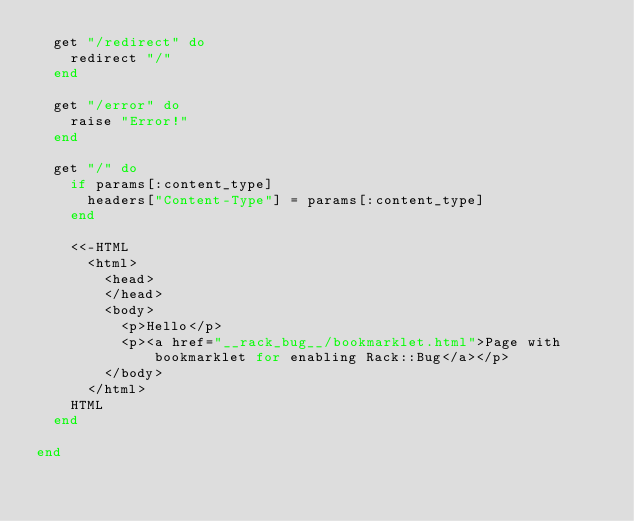Convert code to text. <code><loc_0><loc_0><loc_500><loc_500><_Ruby_>  get "/redirect" do
    redirect "/"
  end

  get "/error" do
    raise "Error!"
  end

  get "/" do
    if params[:content_type]
      headers["Content-Type"] = params[:content_type]
    end

    <<-HTML
      <html>
        <head>
        </head>
        <body>
          <p>Hello</p>
          <p><a href="__rack_bug__/bookmarklet.html">Page with bookmarklet for enabling Rack::Bug</a></p>
        </body>
      </html>
    HTML
  end

end
</code> 